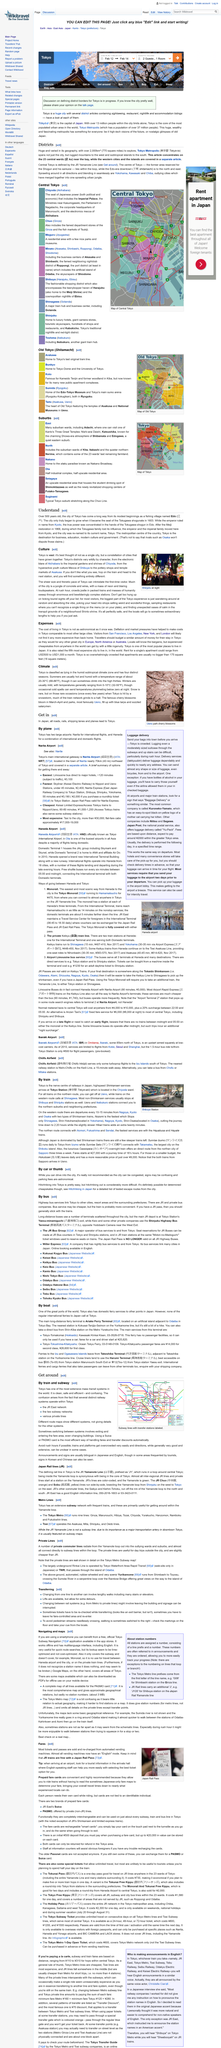Highlight a few significant elements in this photo. The cherry blossoms seen in the photograph bloom in March-April. In Tokyo, snow is rare, indicating that it is not a common occurrence in that location. Tokyo lies in the humid subtropical climate zone, characterized by hot, humid summers and mild winters with occasional snowfall. 